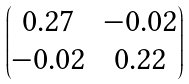Convert formula to latex. <formula><loc_0><loc_0><loc_500><loc_500>\begin{pmatrix} 0 . 2 7 & - 0 . 0 2 \\ - 0 . 0 2 & 0 . 2 2 \end{pmatrix}</formula> 